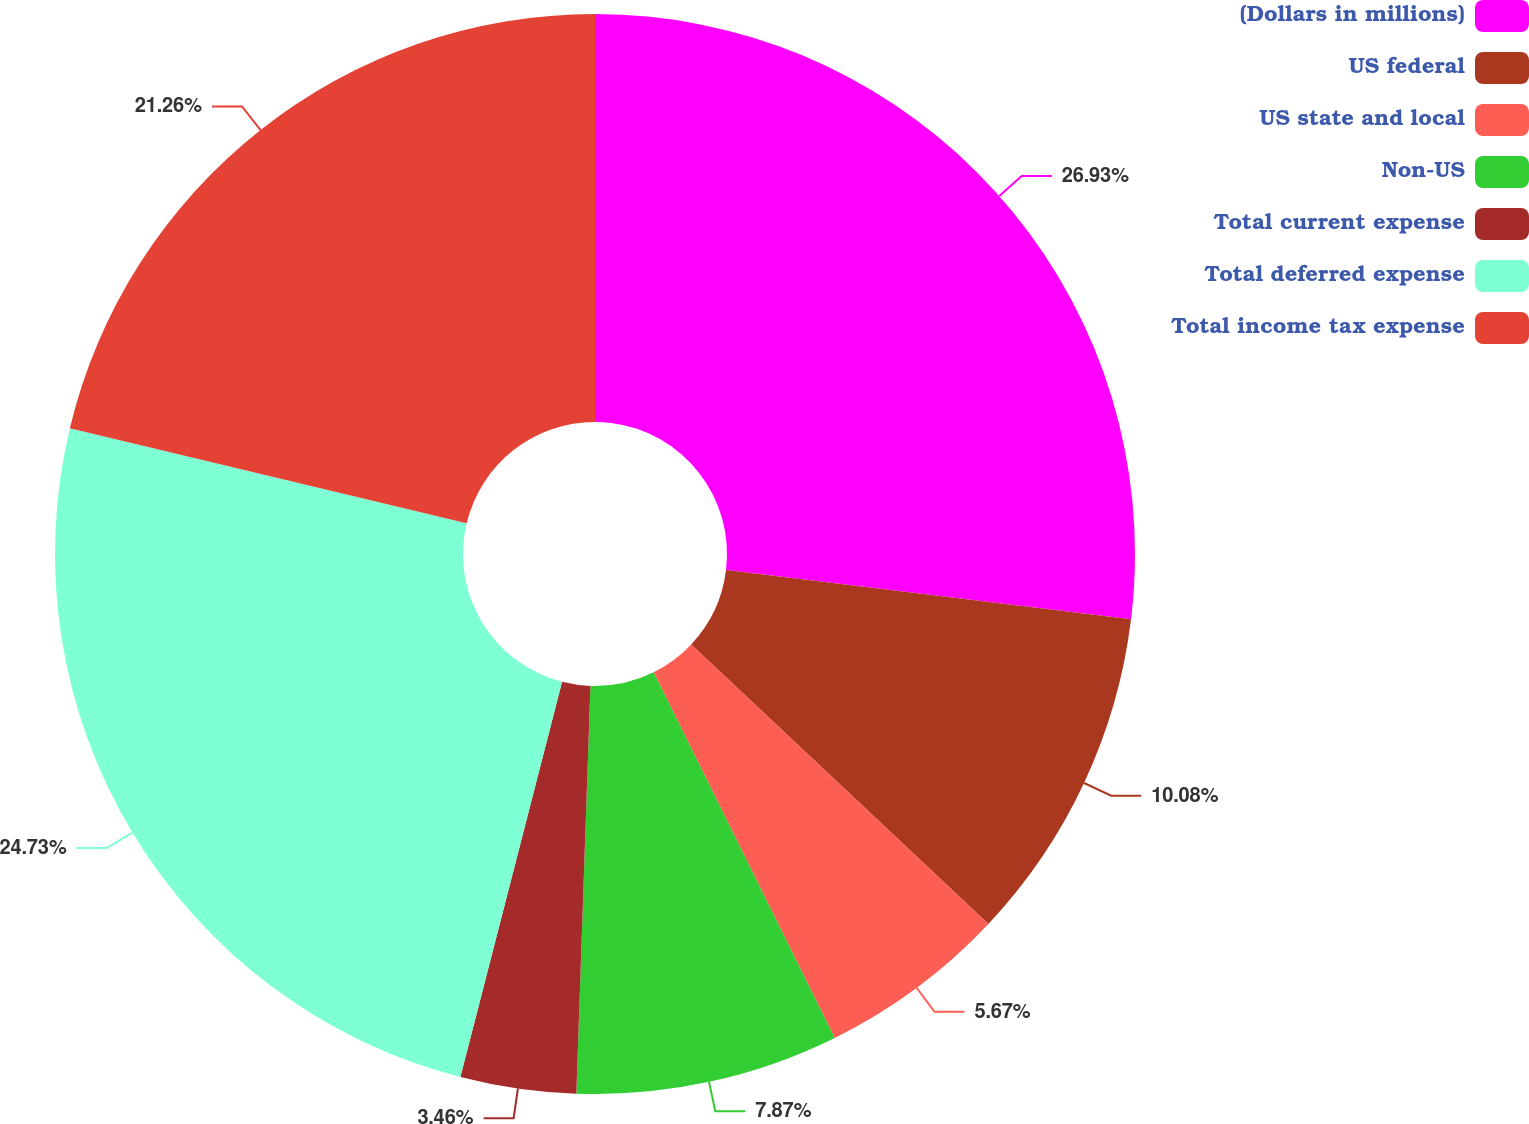Convert chart to OTSL. <chart><loc_0><loc_0><loc_500><loc_500><pie_chart><fcel>(Dollars in millions)<fcel>US federal<fcel>US state and local<fcel>Non-US<fcel>Total current expense<fcel>Total deferred expense<fcel>Total income tax expense<nl><fcel>26.93%<fcel>10.08%<fcel>5.67%<fcel>7.87%<fcel>3.46%<fcel>24.73%<fcel>21.26%<nl></chart> 